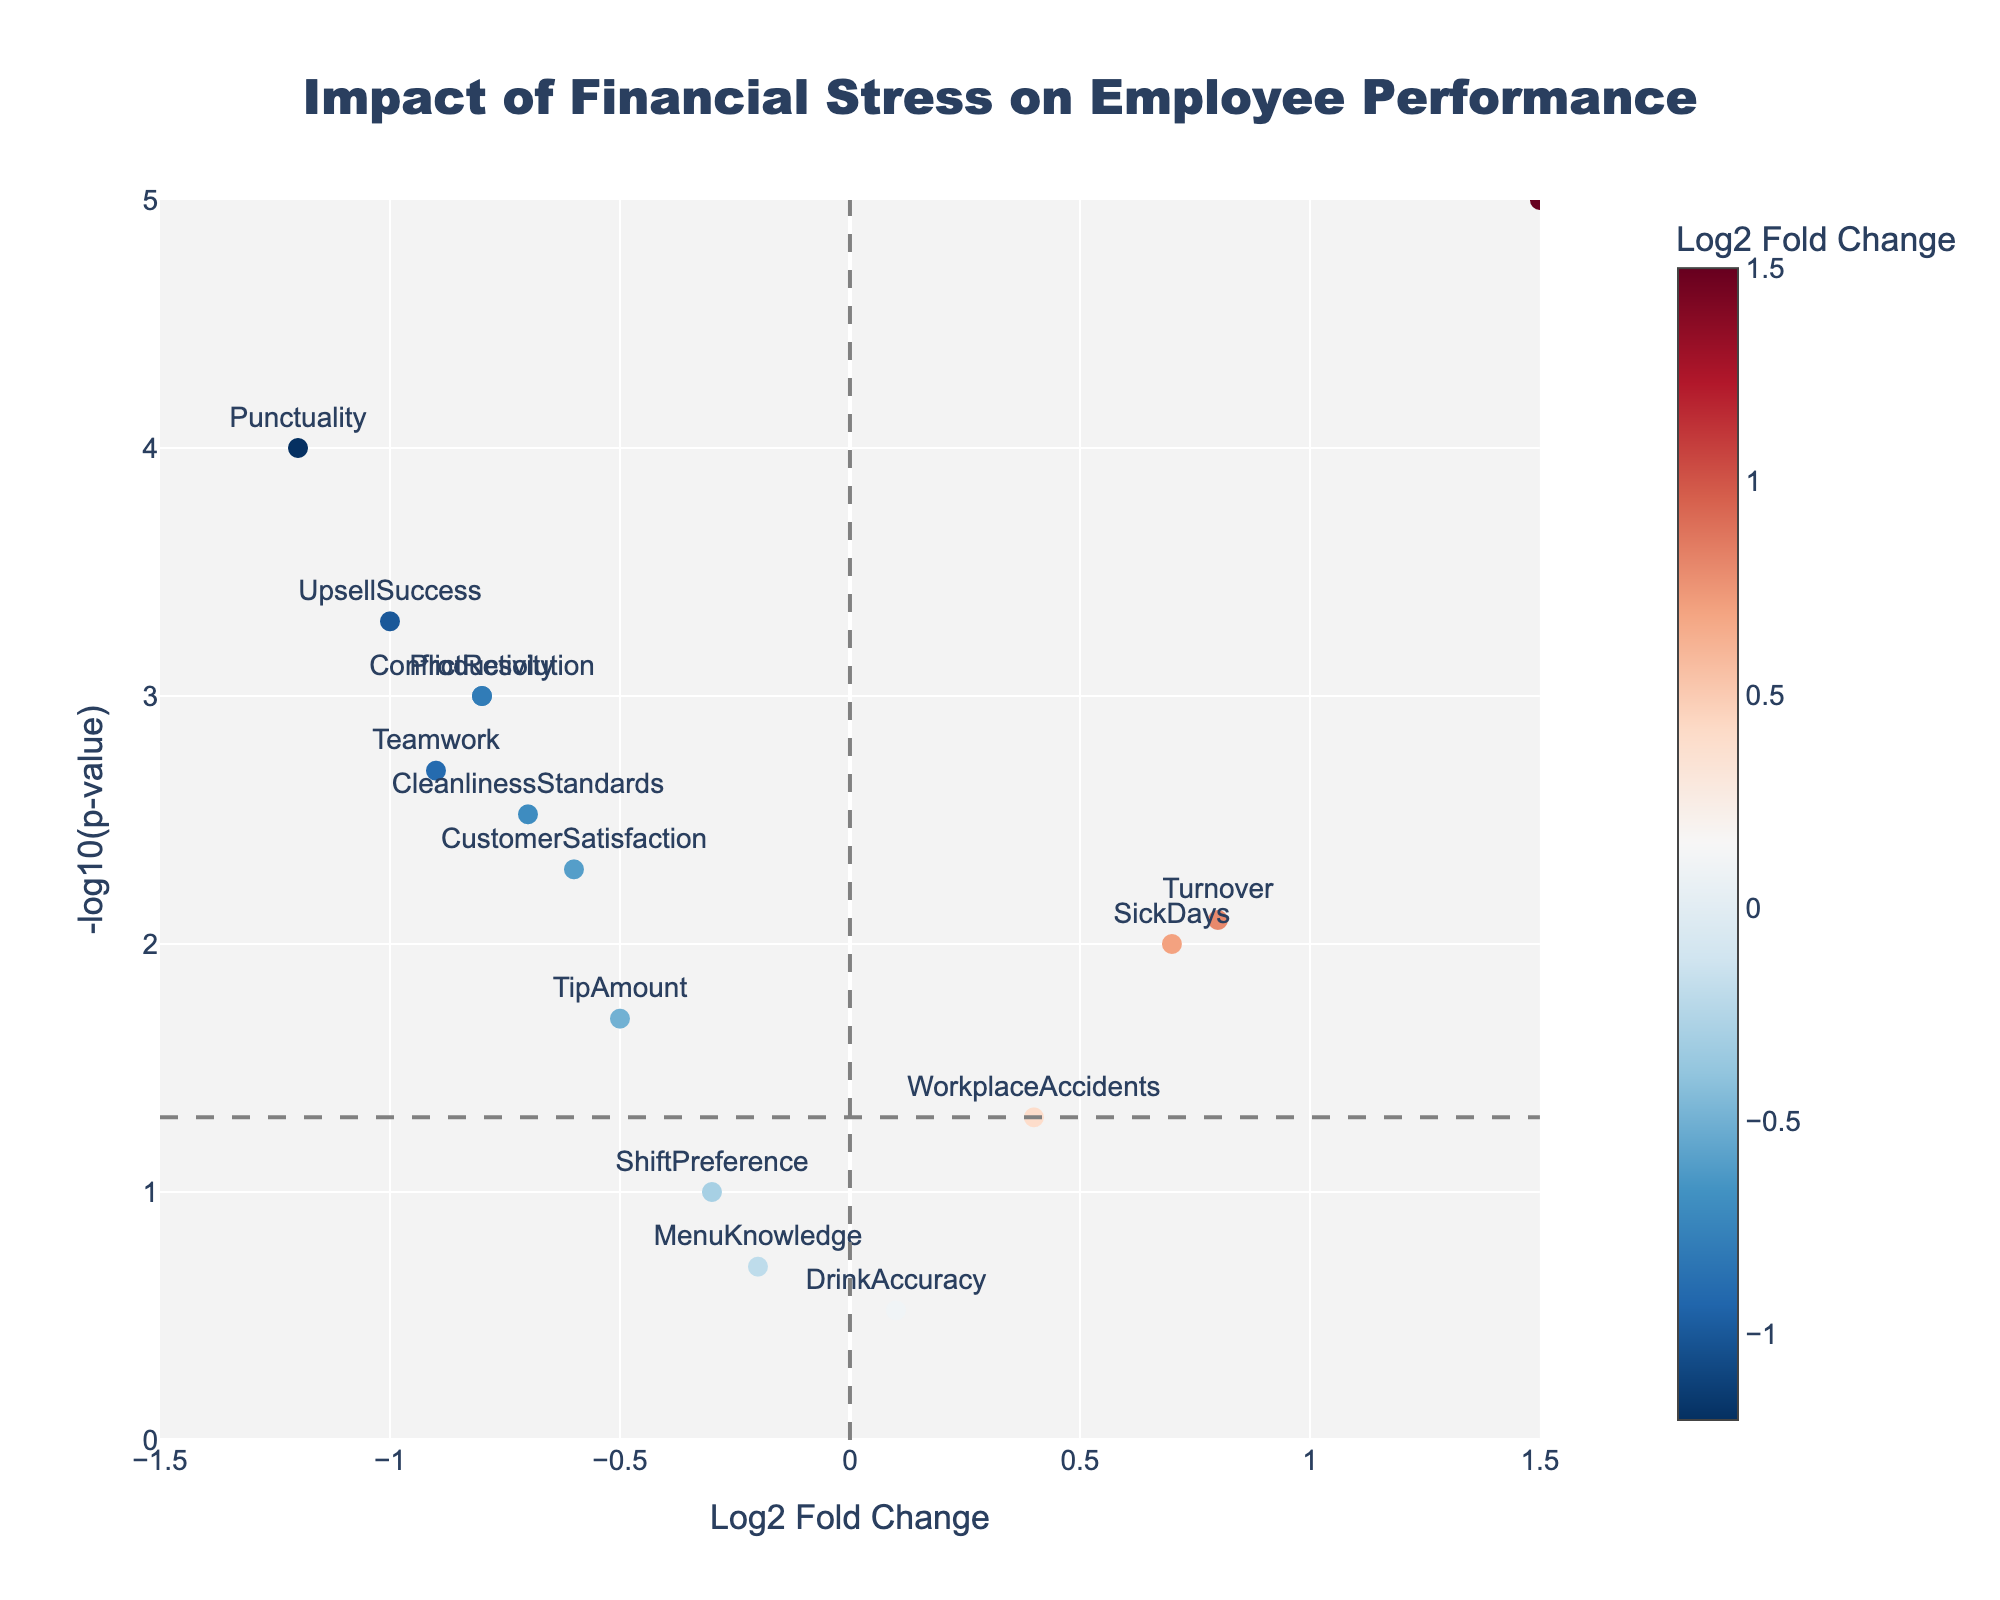How many metrics have statistically significant changes at a p-value threshold of 0.05? In the plot, metrics with a p-value less than 0.05 are above the horizontal gray dashed line, calculated as -log10(0.05) ≈ 1.30. Count the metrics above this line.
Answer: 10 Which metric shows the largest negative impact (lowest Log2 Fold Change) due to financial stress? Look for the metric with the most negative Log2 Fold Change value on the x-axis.
Answer: Punctuality (-1.2) Which metric indicates the highest positive impact (highest Log2 Fold Change) due to financial stress? Identify the metric with the highest Log2 Fold Change value on the x-axis.
Answer: StressLevel (1.5) What is the p-value for the metric "UpsellSuccess"? Locate the point labeled "UpsellSuccess" in the plot and refer to its y-axis value for the -log10(p-value), then convert it back to p-value by performing 10^(-y-axis value).
Answer: 0.0005 How does "CustomerSatisfaction" compare to "CleanlinessStandards" in terms of Log2 Fold Change? Compare the x-axis values of "CustomerSatisfaction" and "CleanlinessStandards".
Answer: CustomerSatisfaction (-0.6) is higher than CleanlinessStandards (-0.7) Which metric has a p-value closest to 0.01? Locate the points near the y-axis position corresponding to -log10(0.01) = 2. Check hover text to find the exact p-values.
Answer: SickDays (0.01) Is "Teamwork" more affected (greater Log2 Fold Change) by financial stress compared to "Turnover"? Compare the Log2 Fold Change values of "Teamwork" and "Turnover".
Answer: No, Teamwork (-0.9) is less affected than Turnover (0.8) What does the vertical gray dashed line represent in the plot? The vertical gray dashed line at x=0 indicates no Log2 Fold Change, meaning no change in the metric.
Answer: No change in metric Among the metrics with significant p-values, which has the smallest absolute Log2 Fold Change? Consider only metrics above the horizontal gray dashed line and find the one closest to the vertical line at x=0.
Answer: DrinkAccuracy (0.1) How many metrics have a negative Log2 Fold Change but are not statistically significant (p > 0.05)? Identify points on the left side of the vertical gray dashed line and below the horizontal gray dashed line.
Answer: 3 